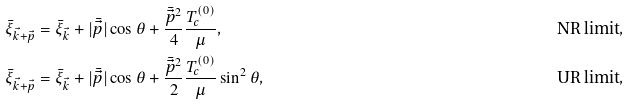Convert formula to latex. <formula><loc_0><loc_0><loc_500><loc_500>\bar { \xi } _ { \vec { k } + \vec { p } } & = \bar { \xi } _ { \vec { k } } + | \bar { \vec { p } } | \cos \theta + \frac { \bar { \vec { p } } ^ { 2 } } { 4 } \frac { T _ { c } ^ { ( 0 ) } } { \mu } , & & \text {NR limit} , \\ \bar { \xi } _ { \vec { k } + \vec { p } } & = \bar { \xi } _ { \vec { k } } + | \bar { \vec { p } } | \cos \theta + \frac { \bar { \vec { p } } ^ { 2 } } { 2 } \frac { T _ { c } ^ { ( 0 ) } } \mu \sin ^ { 2 } \theta , & & \text {UR limit} ,</formula> 